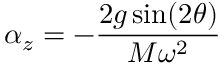Convert formula to latex. <formula><loc_0><loc_0><loc_500><loc_500>\alpha _ { z } = - \frac { 2 g \sin ( 2 \theta ) } { M \omega ^ { 2 } }</formula> 